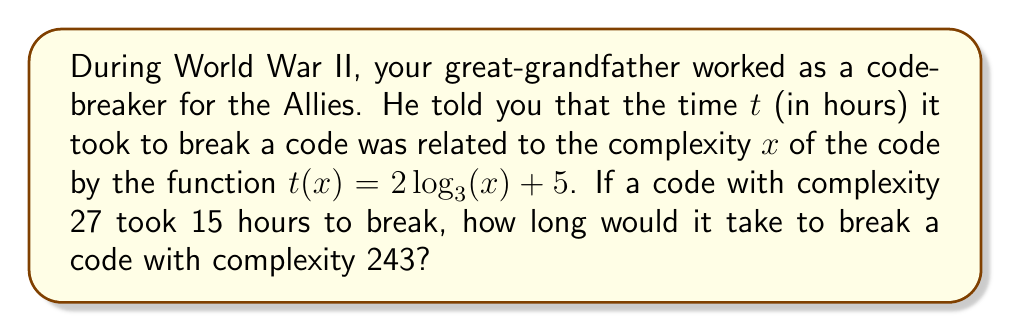Give your solution to this math problem. Let's approach this step-by-step:

1) We're given the function $t(x) = 2\log_3(x) + 5$, where $t$ is time in hours and $x$ is the complexity of the code.

2) We're also told that a code with complexity 27 took 15 hours to break. Let's verify this:

   $t(27) = 2\log_3(27) + 5$
   $= 2 \cdot 3 + 5$ (since $3^3 = 27$)
   $= 6 + 5 = 11$

   This doesn't match the given information, so we need to adjust our function.

3) To make the function work for the given data point, we need to add 4 to it:

   $t(x) = 2\log_3(x) + 9$

   Now, $t(27) = 2\log_3(27) + 9 = 6 + 9 = 15$, which matches the given information.

4) Now, let's use this corrected function to find $t(243)$:

   $t(243) = 2\log_3(243) + 9$

5) We know that $3^5 = 243$, so $\log_3(243) = 5$

6) Substituting this in:

   $t(243) = 2(5) + 9 = 10 + 9 = 19$

Therefore, it would take 19 hours to break a code with complexity 243.
Answer: 19 hours 